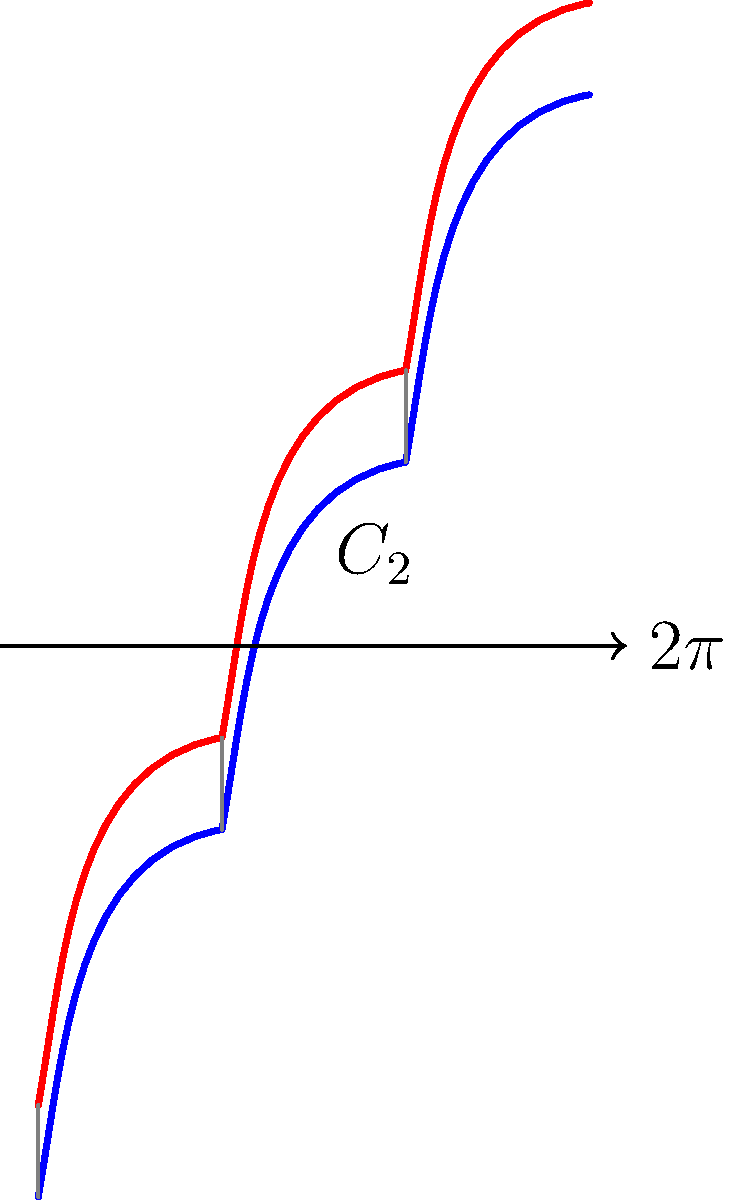Consider the DNA double helix structure shown in the diagram. The blue and red lines represent the two complementary strands. If we apply a $C_2$ rotation (180° rotation around the central axis) followed by a translation of one full turn ($2\pi$) along the helical axis, what group theory operation describes this transformation of the DNA molecule? Let's approach this step-by-step:

1) First, we need to understand the symmetry operations involved:
   - $C_2$ rotation: A 180° rotation around the central axis
   - Translation: A movement along the helical axis by one full turn ($2\pi$)

2) In group theory, a rotation followed by a translation along the rotation axis is called a screw operation.

3) The specific screw operation here is denoted as $2_1$ in the International notation for symmetry elements. This means:
   - The subscript 1 indicates that the translation is by $1/2$ of the repeat distance (one full turn in this case)
   - The 2 indicates a 180° rotation

4) This $2_1$ screw axis is a characteristic symmetry element of the B-form of DNA (the most common form in living organisms).

5) The $2_1$ operation transforms each strand into the other:
   - The blue strand becomes the red strand
   - The red strand becomes the blue strand

6) This operation, when applied twice, brings the structure back to its original configuration, demonstrating its role as a symmetry operation.

Therefore, the group theory operation that describes this transformation is a $2_1$ screw operation.
Answer: $2_1$ screw operation 